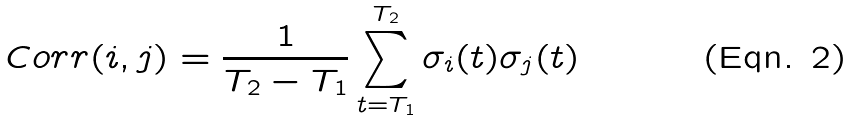<formula> <loc_0><loc_0><loc_500><loc_500>C o r r ( i , j ) = \frac { 1 } { T _ { 2 } - T _ { 1 } } \sum _ { t = T _ { 1 } } ^ { T _ { 2 } } \sigma _ { i } ( t ) \sigma _ { j } ( t )</formula> 